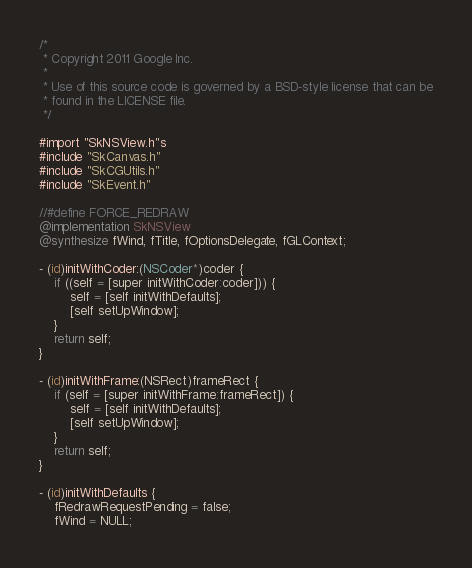<code> <loc_0><loc_0><loc_500><loc_500><_ObjectiveC_>
/*
 * Copyright 2011 Google Inc.
 *
 * Use of this source code is governed by a BSD-style license that can be
 * found in the LICENSE file.
 */

#import "SkNSView.h"s
#include "SkCanvas.h"
#include "SkCGUtils.h"
#include "SkEvent.h"

//#define FORCE_REDRAW
@implementation SkNSView
@synthesize fWind, fTitle, fOptionsDelegate, fGLContext;

- (id)initWithCoder:(NSCoder*)coder {
    if ((self = [super initWithCoder:coder])) {
        self = [self initWithDefaults];
        [self setUpWindow];
    }
    return self;
}

- (id)initWithFrame:(NSRect)frameRect {
    if (self = [super initWithFrame:frameRect]) {
        self = [self initWithDefaults];
        [self setUpWindow];
    }
    return self;
}

- (id)initWithDefaults {
    fRedrawRequestPending = false;
    fWind = NULL;</code> 